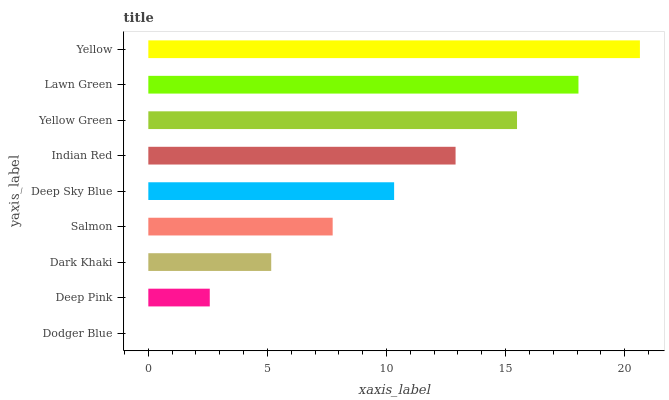Is Dodger Blue the minimum?
Answer yes or no. Yes. Is Yellow the maximum?
Answer yes or no. Yes. Is Deep Pink the minimum?
Answer yes or no. No. Is Deep Pink the maximum?
Answer yes or no. No. Is Deep Pink greater than Dodger Blue?
Answer yes or no. Yes. Is Dodger Blue less than Deep Pink?
Answer yes or no. Yes. Is Dodger Blue greater than Deep Pink?
Answer yes or no. No. Is Deep Pink less than Dodger Blue?
Answer yes or no. No. Is Deep Sky Blue the high median?
Answer yes or no. Yes. Is Deep Sky Blue the low median?
Answer yes or no. Yes. Is Dodger Blue the high median?
Answer yes or no. No. Is Yellow the low median?
Answer yes or no. No. 